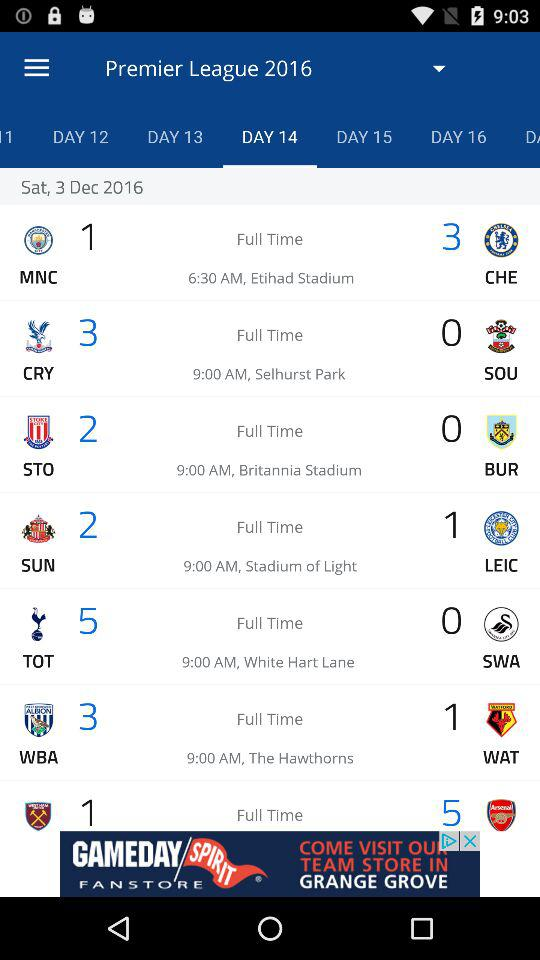What is the match time of MNC vs. CHE? The match time is 6:30 AM. 